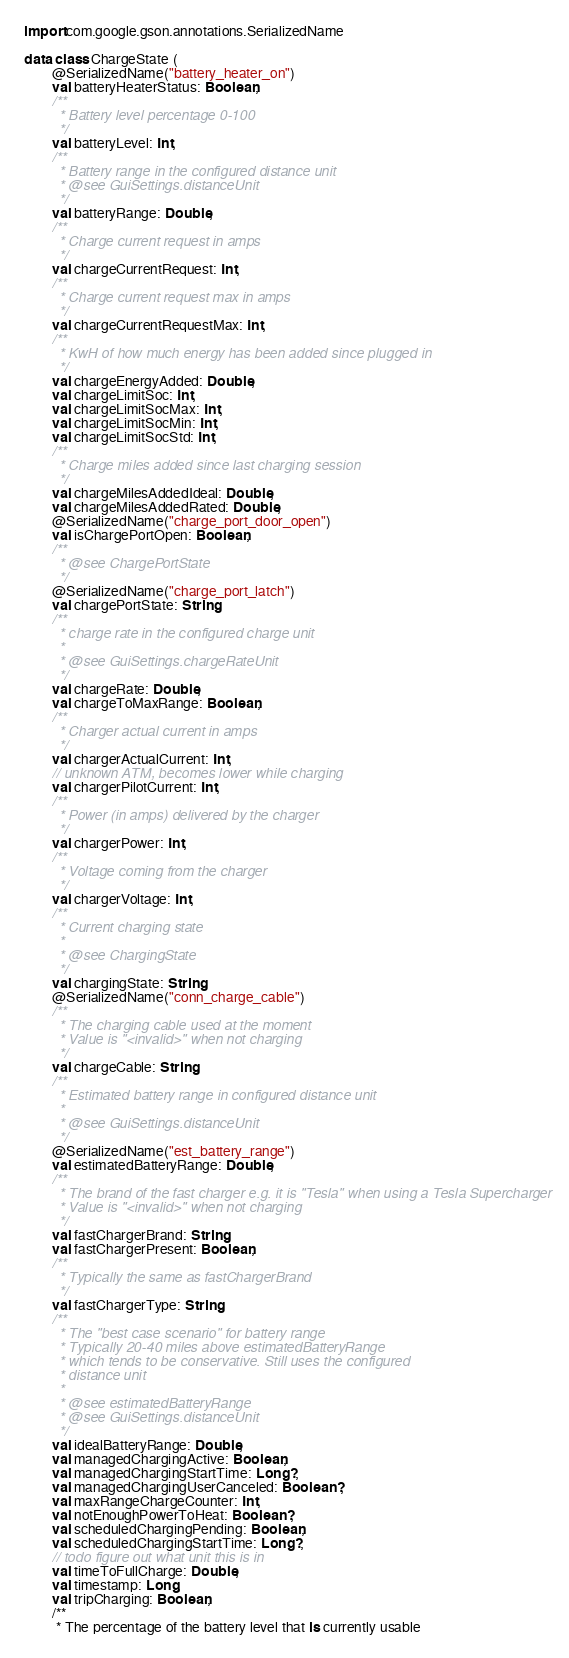<code> <loc_0><loc_0><loc_500><loc_500><_Kotlin_>
import com.google.gson.annotations.SerializedName

data class ChargeState (
        @SerializedName("battery_heater_on")
        val batteryHeaterStatus: Boolean,
        /**
         * Battery level percentage 0-100
         */
        val batteryLevel: Int,
        /**
         * Battery range in the configured distance unit
         * @see GuiSettings.distanceUnit
         */
        val batteryRange: Double,
        /**
         * Charge current request in amps
         */
        val chargeCurrentRequest: Int,
        /**
         * Charge current request max in amps
         */
        val chargeCurrentRequestMax: Int,
        /**
         * KwH of how much energy has been added since plugged in
         */
        val chargeEnergyAdded: Double,
        val chargeLimitSoc: Int,
        val chargeLimitSocMax: Int,
        val chargeLimitSocMin: Int,
        val chargeLimitSocStd: Int,
        /**
         * Charge miles added since last charging session
         */
        val chargeMilesAddedIdeal: Double,
        val chargeMilesAddedRated: Double,
        @SerializedName("charge_port_door_open")
        val isChargePortOpen: Boolean,
        /**
         * @see ChargePortState
         */
        @SerializedName("charge_port_latch")
        val chargePortState: String,
        /**
         * charge rate in the configured charge unit
         *
         * @see GuiSettings.chargeRateUnit
         */
        val chargeRate: Double,
        val chargeToMaxRange: Boolean,
        /**
         * Charger actual current in amps
         */
        val chargerActualCurrent: Int,
        // unknown ATM, becomes lower while charging
        val chargerPilotCurrent: Int,
        /**
         * Power (in amps) delivered by the charger
         */
        val chargerPower: Int,
        /**
         * Voltage coming from the charger
         */
        val chargerVoltage: Int,
        /**
         * Current charging state
         *
         * @see ChargingState
         */
        val chargingState: String,
        @SerializedName("conn_charge_cable")
        /**
         * The charging cable used at the moment
         * Value is "<invalid>" when not charging
         */
        val chargeCable: String,
        /**
         * Estimated battery range in configured distance unit
         *
         * @see GuiSettings.distanceUnit
         */
        @SerializedName("est_battery_range")
        val estimatedBatteryRange: Double,
        /**
         * The brand of the fast charger e.g. it is "Tesla" when using a Tesla Supercharger
         * Value is "<invalid>" when not charging
         */
        val fastChargerBrand: String,
        val fastChargerPresent: Boolean,
        /**
         * Typically the same as fastChargerBrand
         */
        val fastChargerType: String,
        /**
         * The "best case scenario" for battery range
         * Typically 20-40 miles above estimatedBatteryRange
         * which tends to be conservative. Still uses the configured
         * distance unit
         *
         * @see estimatedBatteryRange
         * @see GuiSettings.distanceUnit
         */
        val idealBatteryRange: Double,
        val managedChargingActive: Boolean,
        val managedChargingStartTime: Long?,
        val managedChargingUserCanceled: Boolean?,
        val maxRangeChargeCounter: Int,
        val notEnoughPowerToHeat: Boolean?,
        val scheduledChargingPending: Boolean,
        val scheduledChargingStartTime: Long?,
        // todo figure out what unit this is in
        val timeToFullCharge: Double,
        val timestamp: Long,
        val tripCharging: Boolean,
        /**
         * The percentage of the battery level that is currently usable</code> 